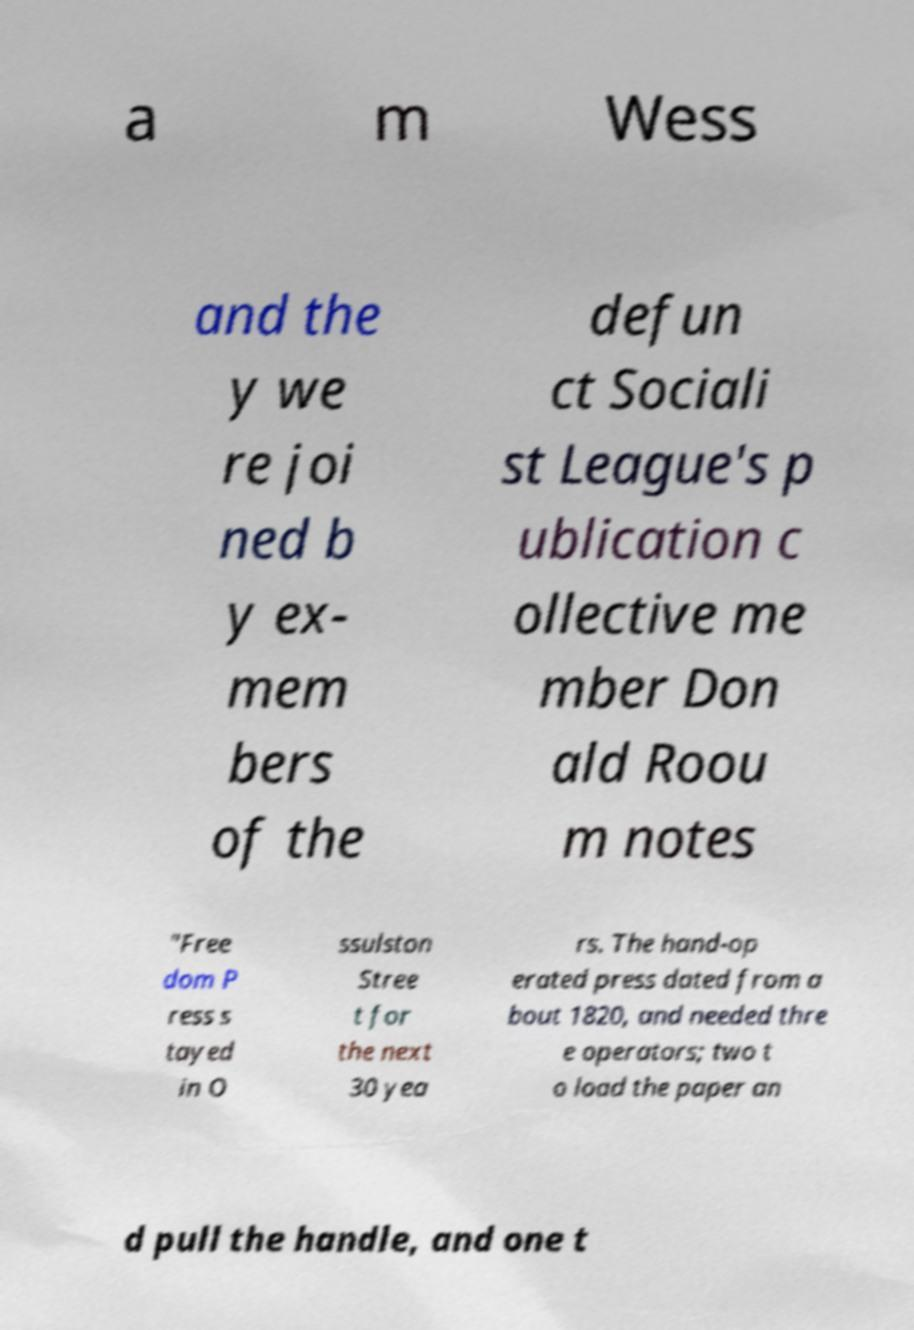I need the written content from this picture converted into text. Can you do that? a m Wess and the y we re joi ned b y ex- mem bers of the defun ct Sociali st League's p ublication c ollective me mber Don ald Roou m notes "Free dom P ress s tayed in O ssulston Stree t for the next 30 yea rs. The hand-op erated press dated from a bout 1820, and needed thre e operators; two t o load the paper an d pull the handle, and one t 